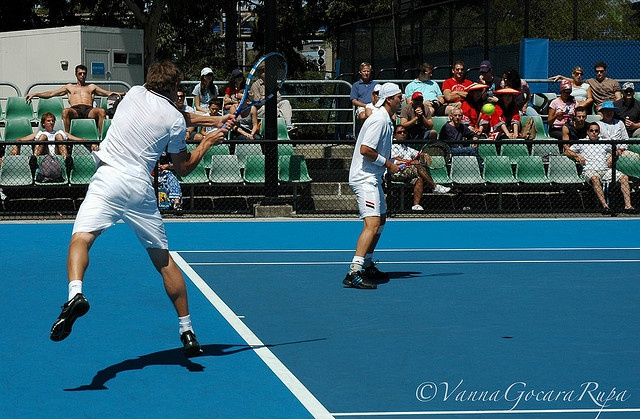Describe the objects in this image and their specific colors. I can see people in black, lightgray, darkgray, and blue tones, people in black, gray, darkgray, and lightgray tones, chair in black, teal, gray, and darkgray tones, truck in black, darkgray, gray, and purple tones, and people in black, lightgray, darkgray, and gray tones in this image. 